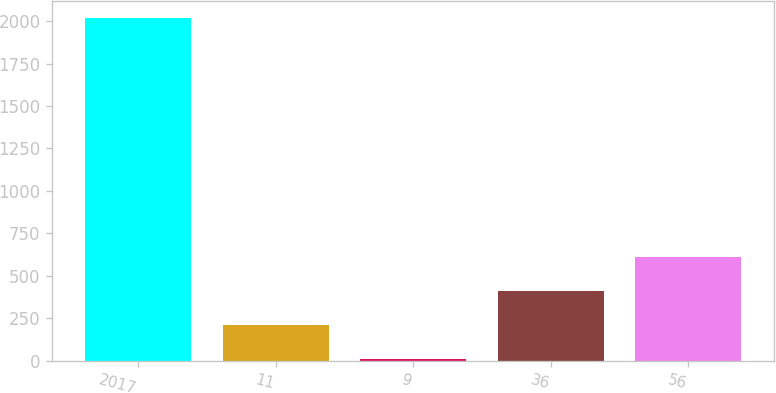Convert chart. <chart><loc_0><loc_0><loc_500><loc_500><bar_chart><fcel>2017<fcel>11<fcel>9<fcel>36<fcel>56<nl><fcel>2016<fcel>208.8<fcel>8<fcel>409.6<fcel>610.4<nl></chart> 